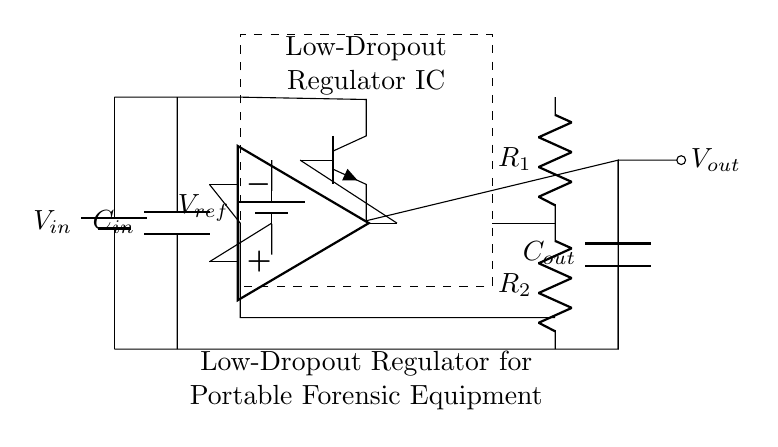What is the input voltage of the circuit? The input voltage is represented by the source labeled V in, which is connected to the top of the circuit.
Answer: V in What type of regulator is shown in this circuit? The circuit diagram depicts a low-dropout regulator, indicated by the term in the dashed rectangle labeled Low-Dropout Regulator IC.
Answer: Low-Dropout Regulator What are the components connected to the output? The output of the regulator connects to the C out capacitor and leads to the output node, which is designated V out.
Answer: C out, V out How many feedback resistors are present? There are two feedback resistors labeled R1 and R2, which are connected in series to provide feedback to the error amplifier in the regulator circuit.
Answer: 2 What is the reference voltage source labeled as? The reference voltage source is labeled as V ref, which is connected to the error amplifier to set the output voltage level of the regulator.
Answer: V ref Which component amplifies the error signal? The error amplifier, represented by the operational amplifier symbol, is responsible for amplifying the error signal that arises from comparing the output voltage with the reference voltage.
Answer: Op amp What role does the pass transistor play in the circuit? The pass transistor, represented by the npn symbol, regulates the current flowing from the input to the output based on the control signal from the error amplifier.
Answer: Regulates current 